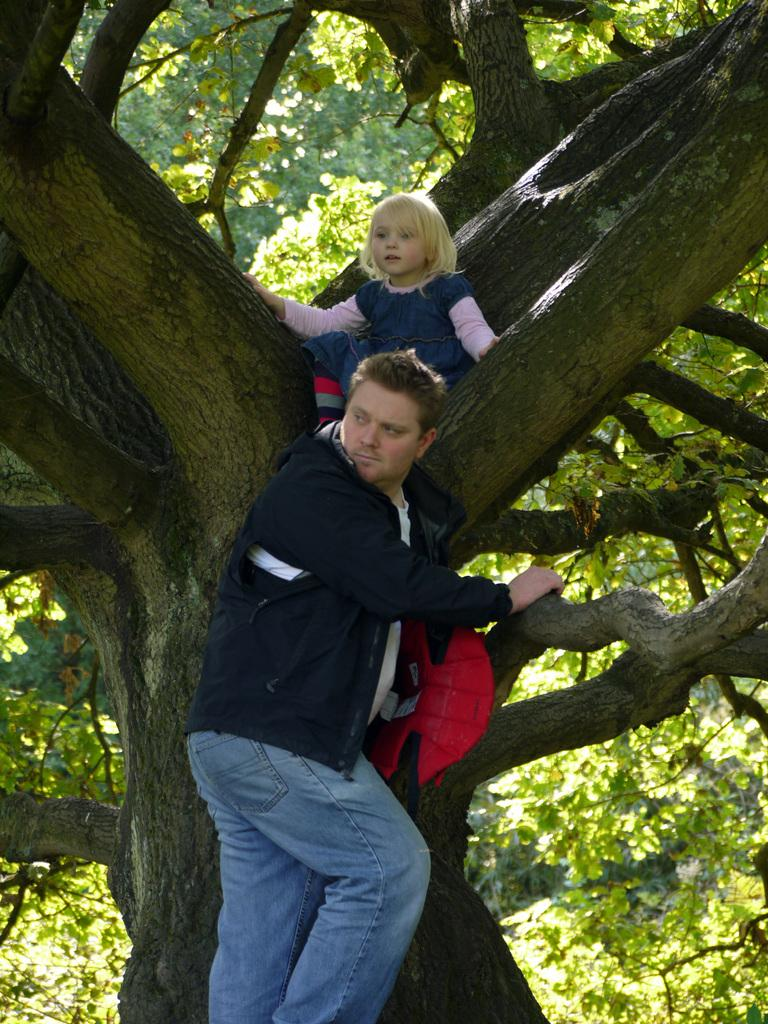What is present in the picture? There is a tree in the picture. What is the girl doing in the picture? A girl is seated on a branch of the tree. What is the man doing in the picture? A man is climbing the tree. What is the fifth element in the picture? There are only three elements present in the picture: the tree, the girl, and the man. The concept of a "fifth element" is not applicable in this context. 